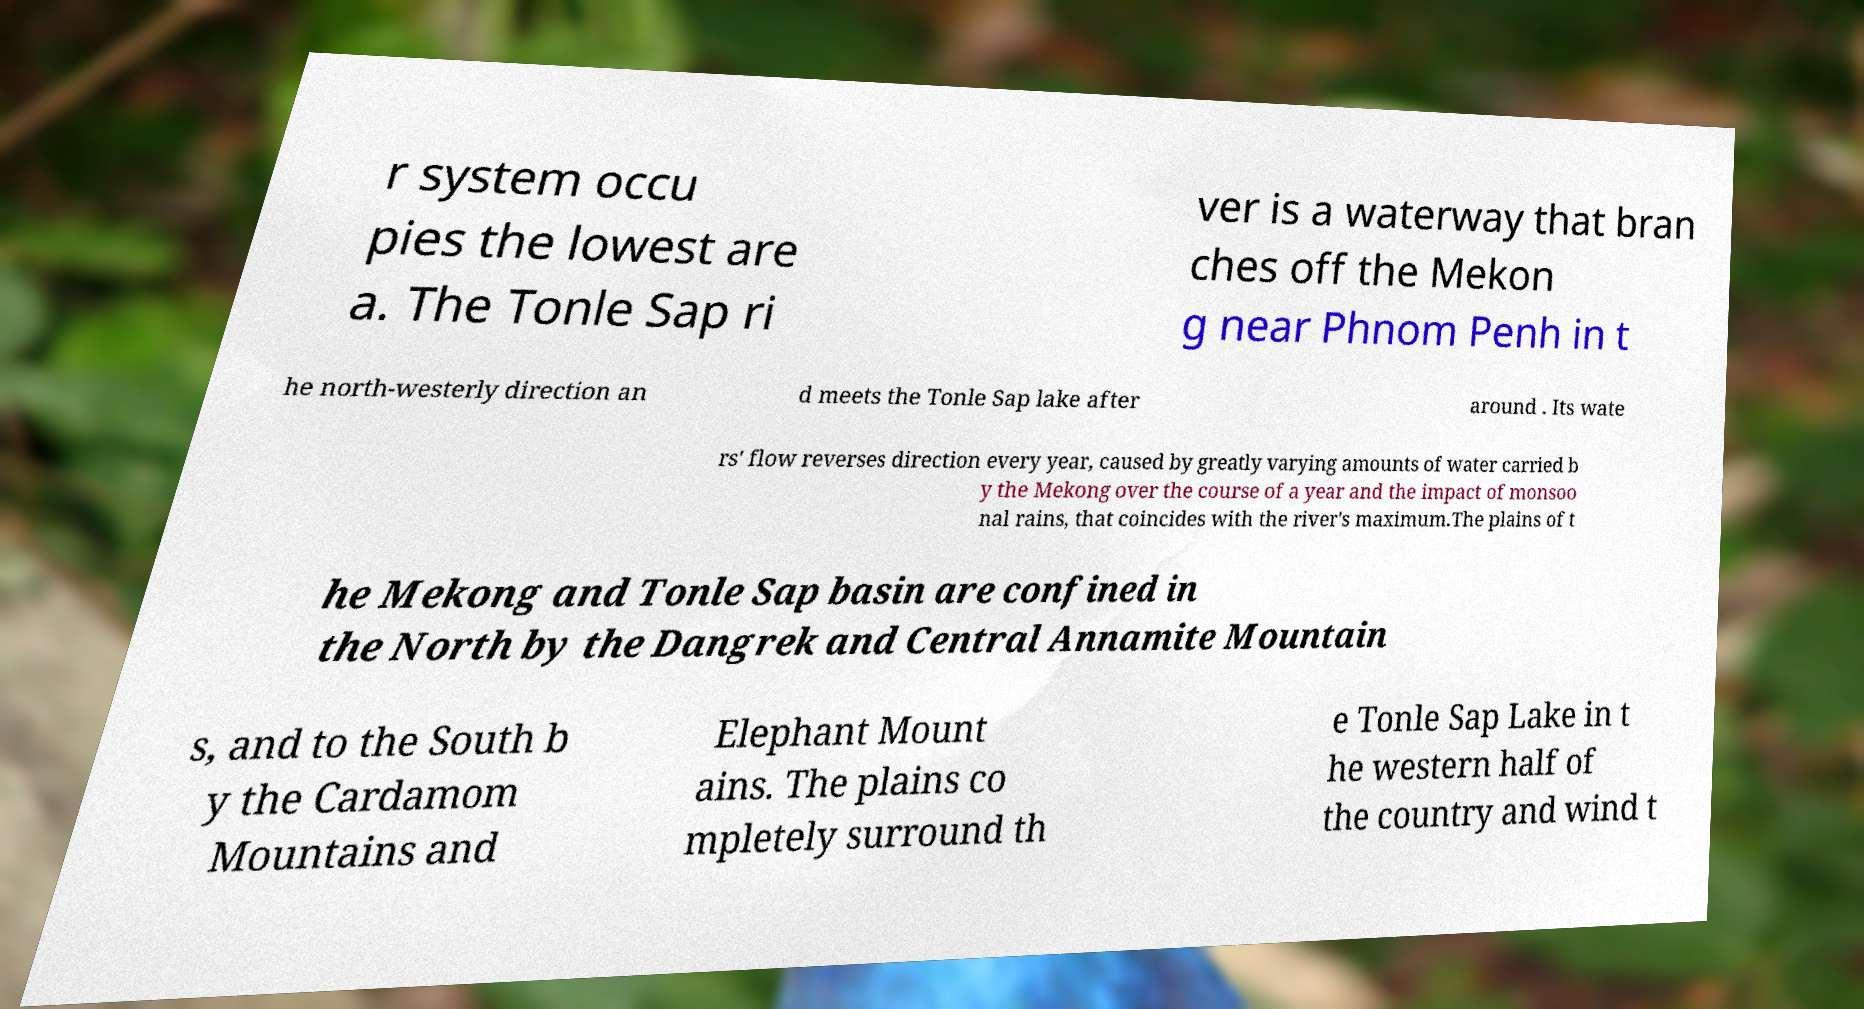Can you read and provide the text displayed in the image?This photo seems to have some interesting text. Can you extract and type it out for me? r system occu pies the lowest are a. The Tonle Sap ri ver is a waterway that bran ches off the Mekon g near Phnom Penh in t he north-westerly direction an d meets the Tonle Sap lake after around . Its wate rs' flow reverses direction every year, caused by greatly varying amounts of water carried b y the Mekong over the course of a year and the impact of monsoo nal rains, that coincides with the river's maximum.The plains of t he Mekong and Tonle Sap basin are confined in the North by the Dangrek and Central Annamite Mountain s, and to the South b y the Cardamom Mountains and Elephant Mount ains. The plains co mpletely surround th e Tonle Sap Lake in t he western half of the country and wind t 